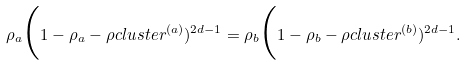<formula> <loc_0><loc_0><loc_500><loc_500>\rho _ { a } \Big ( 1 - \rho _ { a } - \rho c l u s t e r ^ { ( a ) } ) ^ { 2 d - 1 } = \rho _ { b } \Big ( 1 - \rho _ { b } - \rho c l u s t e r ^ { ( b ) } ) ^ { 2 d - 1 } .</formula> 